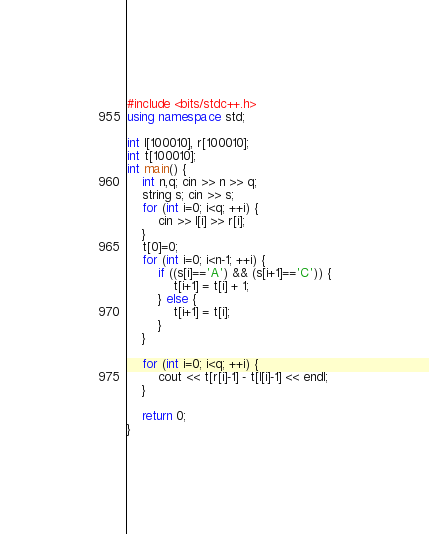Convert code to text. <code><loc_0><loc_0><loc_500><loc_500><_C++_>#include <bits/stdc++.h>
using namespace std;

int l[100010], r[100010];
int t[100010];
int main() {
	int n,q; cin >> n >> q;
	string s; cin >> s;
	for (int i=0; i<q; ++i) {
		cin >> l[i] >> r[i];
	}
	t[0]=0;
	for (int i=0; i<n-1; ++i) {
		if ((s[i]=='A') && (s[i+1]=='C')) {
			t[i+1] = t[i] + 1;
		} else {
			t[i+1] = t[i];
		}
	}
	
	for (int i=0; i<q; ++i) {
		cout << t[r[i]-1] - t[l[i]-1] << endl;
	}	
	
	return 0;
}
</code> 